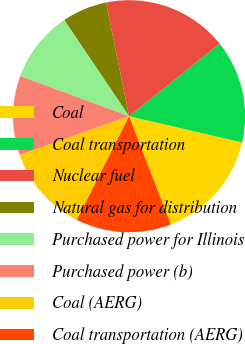Convert chart. <chart><loc_0><loc_0><loc_500><loc_500><pie_chart><fcel>Coal<fcel>Coal transportation<fcel>Nuclear fuel<fcel>Natural gas for distribution<fcel>Purchased power for Illinois<fcel>Purchased power (b)<fcel>Coal (AERG)<fcel>Coal transportation (AERG)<nl><fcel>15.51%<fcel>14.39%<fcel>17.42%<fcel>6.27%<fcel>9.93%<fcel>11.05%<fcel>12.16%<fcel>13.28%<nl></chart> 